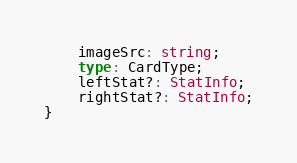Convert code to text. <code><loc_0><loc_0><loc_500><loc_500><_TypeScript_>    imageSrc: string;
    type: CardType;
    leftStat?: StatInfo;
    rightStat?: StatInfo;
}
</code> 